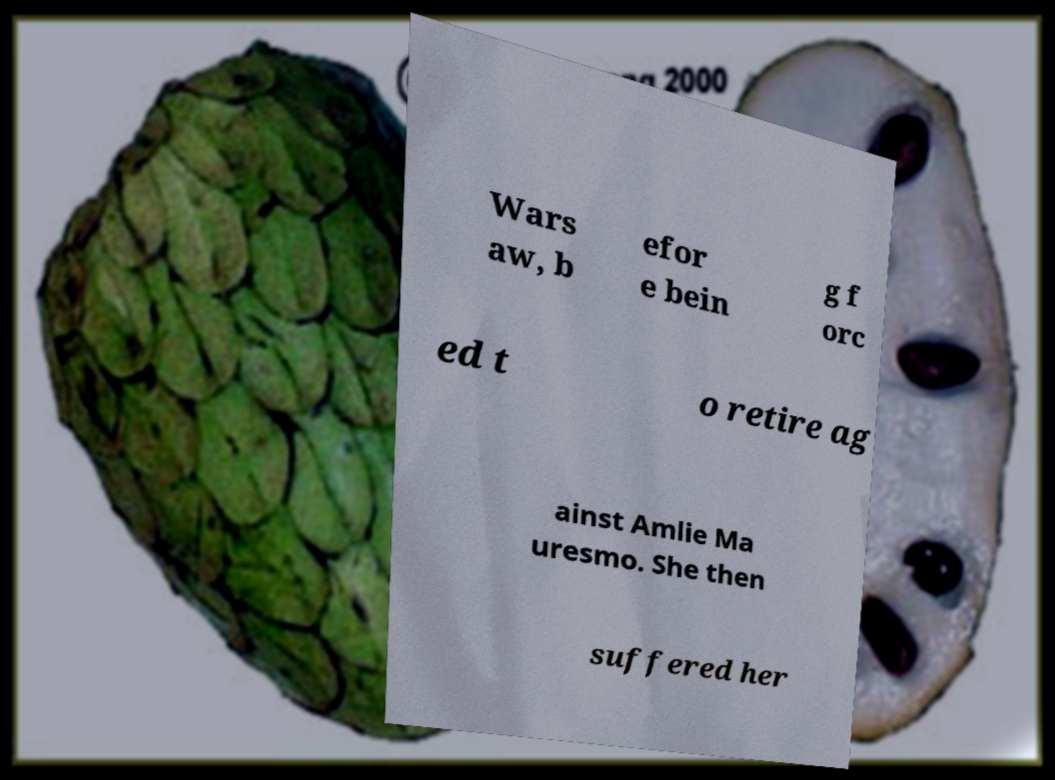Could you extract and type out the text from this image? Wars aw, b efor e bein g f orc ed t o retire ag ainst Amlie Ma uresmo. She then suffered her 